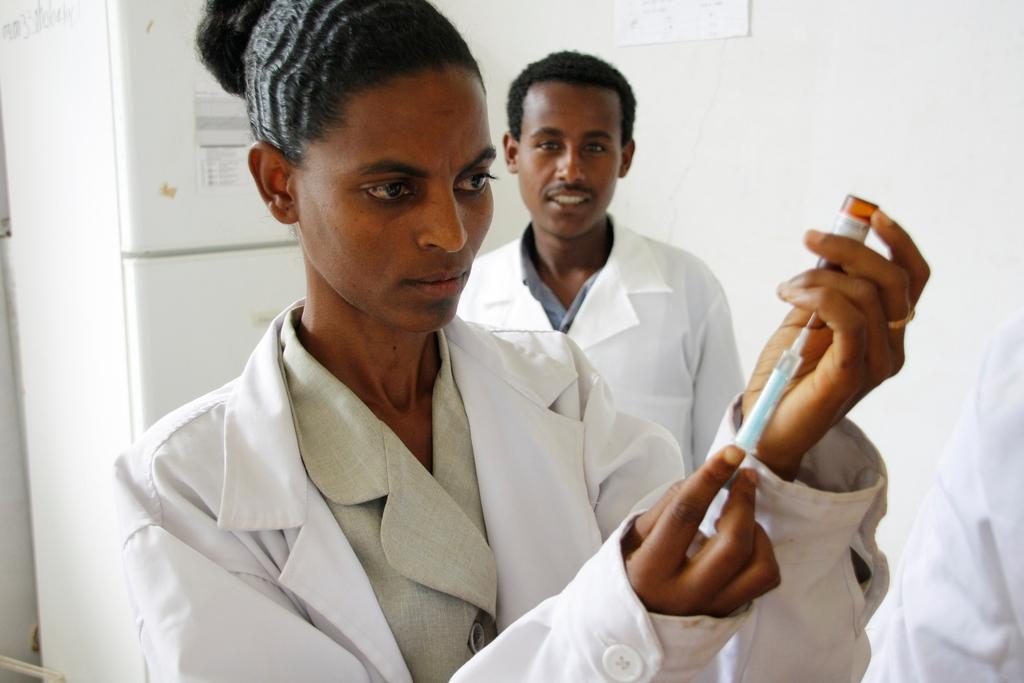Can you describe this image briefly? In the foreground of this picture, there is a woman in white coat holding a syringe and a bottle in her hand. In the background, we can see a man in white coat, a wall and a refrigerator. 